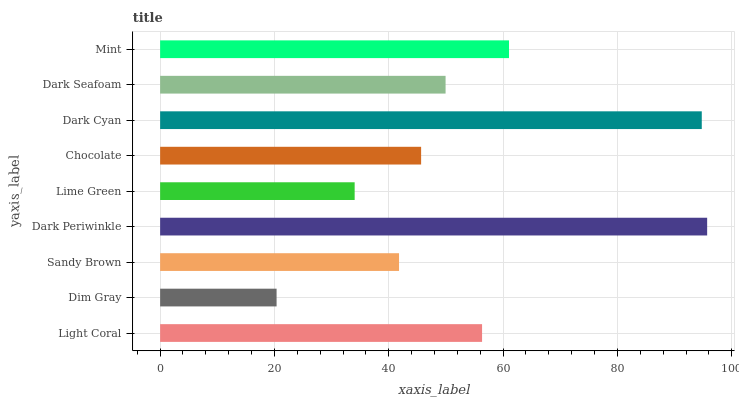Is Dim Gray the minimum?
Answer yes or no. Yes. Is Dark Periwinkle the maximum?
Answer yes or no. Yes. Is Sandy Brown the minimum?
Answer yes or no. No. Is Sandy Brown the maximum?
Answer yes or no. No. Is Sandy Brown greater than Dim Gray?
Answer yes or no. Yes. Is Dim Gray less than Sandy Brown?
Answer yes or no. Yes. Is Dim Gray greater than Sandy Brown?
Answer yes or no. No. Is Sandy Brown less than Dim Gray?
Answer yes or no. No. Is Dark Seafoam the high median?
Answer yes or no. Yes. Is Dark Seafoam the low median?
Answer yes or no. Yes. Is Mint the high median?
Answer yes or no. No. Is Dark Periwinkle the low median?
Answer yes or no. No. 